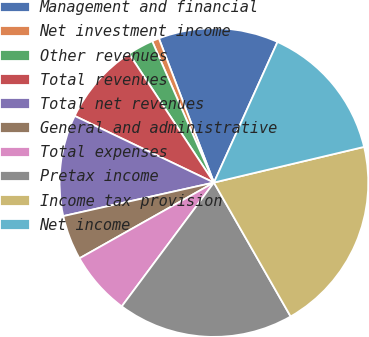<chart> <loc_0><loc_0><loc_500><loc_500><pie_chart><fcel>Management and financial<fcel>Net investment income<fcel>Other revenues<fcel>Total revenues<fcel>Total net revenues<fcel>General and administrative<fcel>Total expenses<fcel>Pretax income<fcel>Income tax provision<fcel>Net income<nl><fcel>12.56%<fcel>0.75%<fcel>2.72%<fcel>8.62%<fcel>10.59%<fcel>4.68%<fcel>6.65%<fcel>18.46%<fcel>20.43%<fcel>14.53%<nl></chart> 